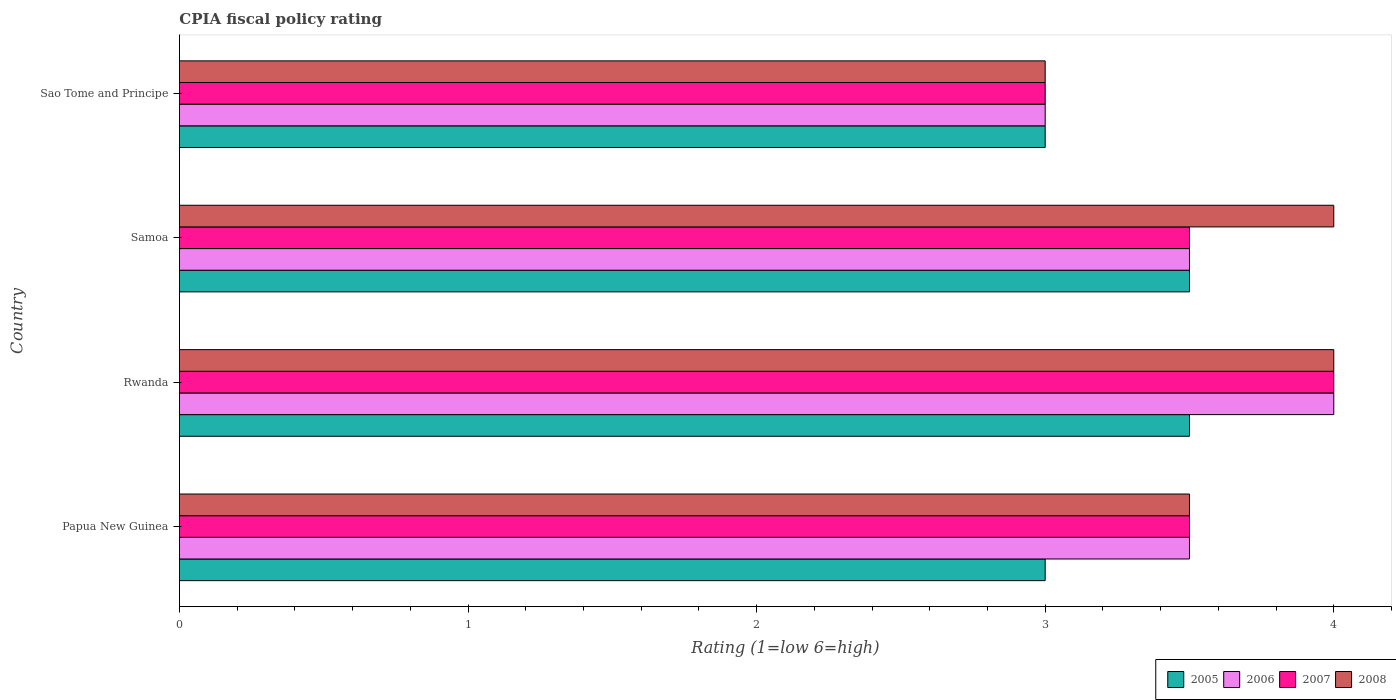How many different coloured bars are there?
Your answer should be compact. 4. How many groups of bars are there?
Provide a short and direct response. 4. Are the number of bars on each tick of the Y-axis equal?
Ensure brevity in your answer.  Yes. How many bars are there on the 3rd tick from the top?
Your response must be concise. 4. How many bars are there on the 2nd tick from the bottom?
Keep it short and to the point. 4. What is the label of the 2nd group of bars from the top?
Give a very brief answer. Samoa. In how many cases, is the number of bars for a given country not equal to the number of legend labels?
Provide a succinct answer. 0. In which country was the CPIA rating in 2008 maximum?
Give a very brief answer. Rwanda. In which country was the CPIA rating in 2005 minimum?
Your response must be concise. Papua New Guinea. What is the total CPIA rating in 2007 in the graph?
Your answer should be compact. 14. What is the difference between the CPIA rating in 2006 in Papua New Guinea and that in Sao Tome and Principe?
Your answer should be compact. 0.5. What is the average CPIA rating in 2008 per country?
Your response must be concise. 3.62. In how many countries, is the CPIA rating in 2006 greater than 2 ?
Ensure brevity in your answer.  4. Is the difference between the CPIA rating in 2008 in Papua New Guinea and Rwanda greater than the difference between the CPIA rating in 2006 in Papua New Guinea and Rwanda?
Your answer should be compact. No. What is the difference between the highest and the second highest CPIA rating in 2007?
Your answer should be compact. 0.5. What is the difference between the highest and the lowest CPIA rating in 2007?
Make the answer very short. 1. In how many countries, is the CPIA rating in 2005 greater than the average CPIA rating in 2005 taken over all countries?
Provide a short and direct response. 2. Is the sum of the CPIA rating in 2008 in Papua New Guinea and Rwanda greater than the maximum CPIA rating in 2006 across all countries?
Keep it short and to the point. Yes. Is it the case that in every country, the sum of the CPIA rating in 2008 and CPIA rating in 2006 is greater than the sum of CPIA rating in 2007 and CPIA rating in 2005?
Your response must be concise. No. What does the 1st bar from the top in Rwanda represents?
Offer a very short reply. 2008. Is it the case that in every country, the sum of the CPIA rating in 2007 and CPIA rating in 2008 is greater than the CPIA rating in 2005?
Offer a terse response. Yes. How many bars are there?
Make the answer very short. 16. Are all the bars in the graph horizontal?
Keep it short and to the point. Yes. How many legend labels are there?
Your answer should be compact. 4. What is the title of the graph?
Offer a very short reply. CPIA fiscal policy rating. Does "1964" appear as one of the legend labels in the graph?
Offer a terse response. No. What is the Rating (1=low 6=high) of 2006 in Papua New Guinea?
Offer a terse response. 3.5. What is the Rating (1=low 6=high) in 2005 in Rwanda?
Your answer should be compact. 3.5. What is the Rating (1=low 6=high) of 2007 in Rwanda?
Give a very brief answer. 4. What is the Rating (1=low 6=high) in 2008 in Samoa?
Give a very brief answer. 4. What is the Rating (1=low 6=high) in 2005 in Sao Tome and Principe?
Keep it short and to the point. 3. What is the Rating (1=low 6=high) of 2008 in Sao Tome and Principe?
Your response must be concise. 3. Across all countries, what is the maximum Rating (1=low 6=high) of 2006?
Make the answer very short. 4. Across all countries, what is the maximum Rating (1=low 6=high) in 2007?
Ensure brevity in your answer.  4. Across all countries, what is the minimum Rating (1=low 6=high) in 2005?
Give a very brief answer. 3. Across all countries, what is the minimum Rating (1=low 6=high) in 2006?
Provide a succinct answer. 3. Across all countries, what is the minimum Rating (1=low 6=high) in 2007?
Keep it short and to the point. 3. What is the total Rating (1=low 6=high) in 2005 in the graph?
Provide a succinct answer. 13. What is the difference between the Rating (1=low 6=high) in 2005 in Papua New Guinea and that in Rwanda?
Provide a short and direct response. -0.5. What is the difference between the Rating (1=low 6=high) of 2006 in Papua New Guinea and that in Rwanda?
Provide a succinct answer. -0.5. What is the difference between the Rating (1=low 6=high) in 2008 in Papua New Guinea and that in Rwanda?
Give a very brief answer. -0.5. What is the difference between the Rating (1=low 6=high) of 2006 in Papua New Guinea and that in Samoa?
Ensure brevity in your answer.  0. What is the difference between the Rating (1=low 6=high) in 2007 in Papua New Guinea and that in Samoa?
Provide a short and direct response. 0. What is the difference between the Rating (1=low 6=high) in 2006 in Papua New Guinea and that in Sao Tome and Principe?
Your response must be concise. 0.5. What is the difference between the Rating (1=low 6=high) in 2007 in Papua New Guinea and that in Sao Tome and Principe?
Your response must be concise. 0.5. What is the difference between the Rating (1=low 6=high) in 2005 in Rwanda and that in Samoa?
Offer a very short reply. 0. What is the difference between the Rating (1=low 6=high) in 2007 in Rwanda and that in Samoa?
Make the answer very short. 0.5. What is the difference between the Rating (1=low 6=high) of 2008 in Rwanda and that in Sao Tome and Principe?
Offer a terse response. 1. What is the difference between the Rating (1=low 6=high) in 2006 in Samoa and that in Sao Tome and Principe?
Provide a short and direct response. 0.5. What is the difference between the Rating (1=low 6=high) of 2007 in Samoa and that in Sao Tome and Principe?
Offer a very short reply. 0.5. What is the difference between the Rating (1=low 6=high) of 2005 in Papua New Guinea and the Rating (1=low 6=high) of 2006 in Rwanda?
Make the answer very short. -1. What is the difference between the Rating (1=low 6=high) of 2005 in Papua New Guinea and the Rating (1=low 6=high) of 2007 in Rwanda?
Your answer should be very brief. -1. What is the difference between the Rating (1=low 6=high) of 2005 in Papua New Guinea and the Rating (1=low 6=high) of 2008 in Rwanda?
Provide a succinct answer. -1. What is the difference between the Rating (1=low 6=high) in 2006 in Papua New Guinea and the Rating (1=low 6=high) in 2008 in Rwanda?
Offer a terse response. -0.5. What is the difference between the Rating (1=low 6=high) in 2005 in Papua New Guinea and the Rating (1=low 6=high) in 2008 in Samoa?
Your response must be concise. -1. What is the difference between the Rating (1=low 6=high) in 2006 in Papua New Guinea and the Rating (1=low 6=high) in 2008 in Samoa?
Offer a very short reply. -0.5. What is the difference between the Rating (1=low 6=high) of 2005 in Papua New Guinea and the Rating (1=low 6=high) of 2006 in Sao Tome and Principe?
Keep it short and to the point. 0. What is the difference between the Rating (1=low 6=high) in 2005 in Papua New Guinea and the Rating (1=low 6=high) in 2008 in Sao Tome and Principe?
Offer a very short reply. 0. What is the difference between the Rating (1=low 6=high) of 2006 in Papua New Guinea and the Rating (1=low 6=high) of 2007 in Sao Tome and Principe?
Offer a terse response. 0.5. What is the difference between the Rating (1=low 6=high) of 2005 in Rwanda and the Rating (1=low 6=high) of 2006 in Samoa?
Your answer should be compact. 0. What is the difference between the Rating (1=low 6=high) of 2006 in Rwanda and the Rating (1=low 6=high) of 2007 in Samoa?
Ensure brevity in your answer.  0.5. What is the difference between the Rating (1=low 6=high) of 2006 in Rwanda and the Rating (1=low 6=high) of 2008 in Samoa?
Keep it short and to the point. 0. What is the difference between the Rating (1=low 6=high) in 2007 in Rwanda and the Rating (1=low 6=high) in 2008 in Samoa?
Offer a very short reply. 0. What is the difference between the Rating (1=low 6=high) in 2005 in Rwanda and the Rating (1=low 6=high) in 2007 in Sao Tome and Principe?
Give a very brief answer. 0.5. What is the difference between the Rating (1=low 6=high) of 2007 in Rwanda and the Rating (1=low 6=high) of 2008 in Sao Tome and Principe?
Your response must be concise. 1. What is the difference between the Rating (1=low 6=high) in 2005 in Samoa and the Rating (1=low 6=high) in 2006 in Sao Tome and Principe?
Offer a terse response. 0.5. What is the difference between the Rating (1=low 6=high) in 2005 in Samoa and the Rating (1=low 6=high) in 2007 in Sao Tome and Principe?
Give a very brief answer. 0.5. What is the difference between the Rating (1=low 6=high) of 2006 in Samoa and the Rating (1=low 6=high) of 2007 in Sao Tome and Principe?
Give a very brief answer. 0.5. What is the difference between the Rating (1=low 6=high) of 2006 in Samoa and the Rating (1=low 6=high) of 2008 in Sao Tome and Principe?
Offer a terse response. 0.5. What is the difference between the Rating (1=low 6=high) of 2007 in Samoa and the Rating (1=low 6=high) of 2008 in Sao Tome and Principe?
Give a very brief answer. 0.5. What is the average Rating (1=low 6=high) in 2005 per country?
Provide a succinct answer. 3.25. What is the average Rating (1=low 6=high) of 2006 per country?
Offer a terse response. 3.5. What is the average Rating (1=low 6=high) in 2008 per country?
Ensure brevity in your answer.  3.62. What is the difference between the Rating (1=low 6=high) in 2005 and Rating (1=low 6=high) in 2006 in Papua New Guinea?
Your answer should be very brief. -0.5. What is the difference between the Rating (1=low 6=high) in 2005 and Rating (1=low 6=high) in 2008 in Papua New Guinea?
Give a very brief answer. -0.5. What is the difference between the Rating (1=low 6=high) in 2006 and Rating (1=low 6=high) in 2007 in Papua New Guinea?
Your response must be concise. 0. What is the difference between the Rating (1=low 6=high) in 2005 and Rating (1=low 6=high) in 2007 in Rwanda?
Your response must be concise. -0.5. What is the difference between the Rating (1=low 6=high) in 2005 and Rating (1=low 6=high) in 2008 in Rwanda?
Provide a succinct answer. -0.5. What is the difference between the Rating (1=low 6=high) of 2006 and Rating (1=low 6=high) of 2007 in Rwanda?
Give a very brief answer. 0. What is the difference between the Rating (1=low 6=high) in 2006 and Rating (1=low 6=high) in 2008 in Rwanda?
Give a very brief answer. 0. What is the difference between the Rating (1=low 6=high) in 2007 and Rating (1=low 6=high) in 2008 in Rwanda?
Your response must be concise. 0. What is the difference between the Rating (1=low 6=high) of 2005 and Rating (1=low 6=high) of 2006 in Samoa?
Your response must be concise. 0. What is the difference between the Rating (1=low 6=high) of 2006 and Rating (1=low 6=high) of 2008 in Samoa?
Your response must be concise. -0.5. What is the difference between the Rating (1=low 6=high) in 2005 and Rating (1=low 6=high) in 2007 in Sao Tome and Principe?
Make the answer very short. 0. What is the difference between the Rating (1=low 6=high) of 2006 and Rating (1=low 6=high) of 2007 in Sao Tome and Principe?
Ensure brevity in your answer.  0. What is the difference between the Rating (1=low 6=high) of 2007 and Rating (1=low 6=high) of 2008 in Sao Tome and Principe?
Offer a terse response. 0. What is the ratio of the Rating (1=low 6=high) of 2005 in Papua New Guinea to that in Rwanda?
Give a very brief answer. 0.86. What is the ratio of the Rating (1=low 6=high) of 2005 in Papua New Guinea to that in Samoa?
Provide a succinct answer. 0.86. What is the ratio of the Rating (1=low 6=high) in 2005 in Papua New Guinea to that in Sao Tome and Principe?
Your answer should be compact. 1. What is the ratio of the Rating (1=low 6=high) in 2007 in Papua New Guinea to that in Sao Tome and Principe?
Your answer should be very brief. 1.17. What is the ratio of the Rating (1=low 6=high) in 2008 in Papua New Guinea to that in Sao Tome and Principe?
Ensure brevity in your answer.  1.17. What is the ratio of the Rating (1=low 6=high) in 2007 in Rwanda to that in Samoa?
Give a very brief answer. 1.14. What is the ratio of the Rating (1=low 6=high) of 2005 in Samoa to that in Sao Tome and Principe?
Make the answer very short. 1.17. What is the difference between the highest and the second highest Rating (1=low 6=high) of 2008?
Keep it short and to the point. 0. What is the difference between the highest and the lowest Rating (1=low 6=high) of 2005?
Your response must be concise. 0.5. What is the difference between the highest and the lowest Rating (1=low 6=high) in 2006?
Provide a succinct answer. 1. What is the difference between the highest and the lowest Rating (1=low 6=high) of 2007?
Provide a short and direct response. 1. 